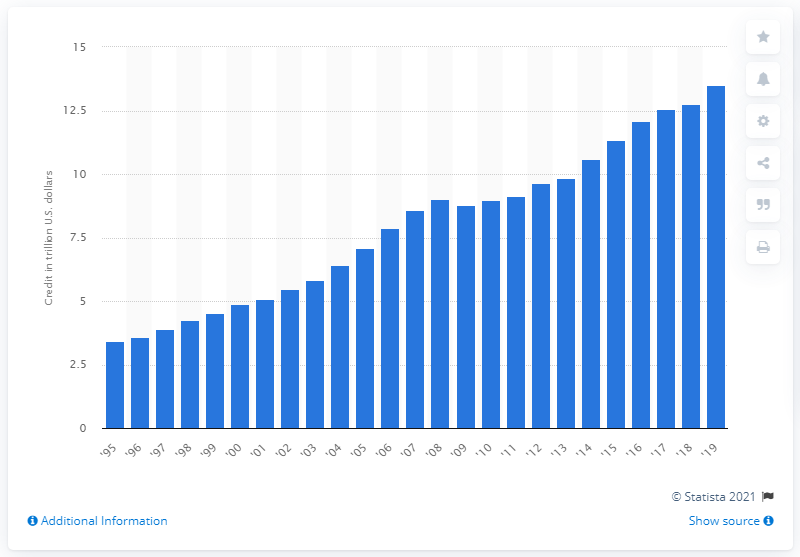Highlight a few significant elements in this photo. In 2019, the total credit provided by all commercial banks to their customers amounted to 13.5 billion dollars. 